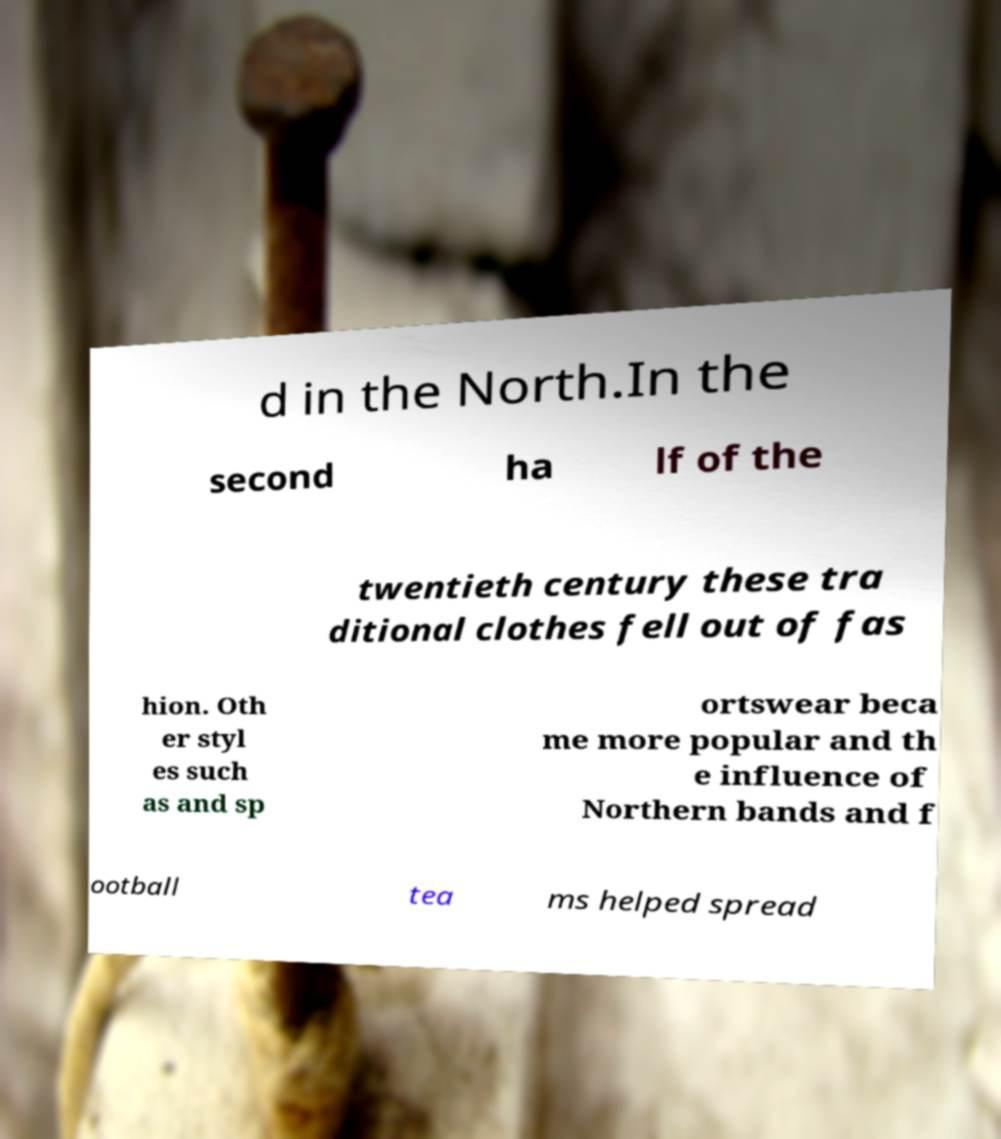I need the written content from this picture converted into text. Can you do that? d in the North.In the second ha lf of the twentieth century these tra ditional clothes fell out of fas hion. Oth er styl es such as and sp ortswear beca me more popular and th e influence of Northern bands and f ootball tea ms helped spread 